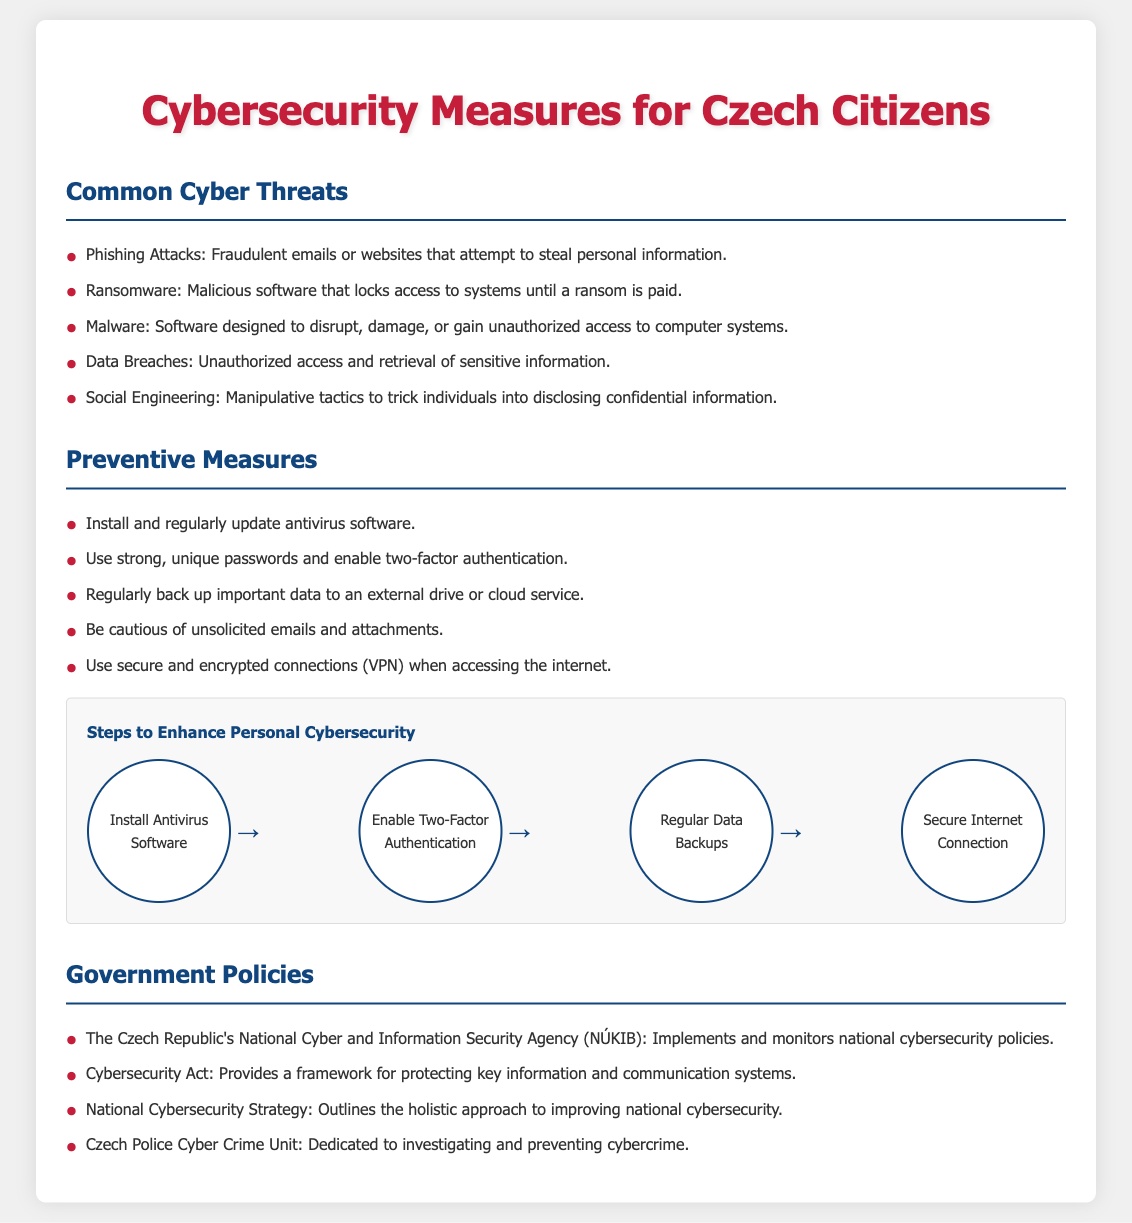What are common cyber threats mentioned? The document lists phishing, ransomware, malware, data breaches, and social engineering as common threats.
Answer: phishing, ransomware, malware, data breaches, social engineering What does NÚKIB stand for? NÚKIB is the abbreviation for the National Cyber and Information Security Agency in the Czech Republic.
Answer: Národní úřad pro kybernetickou a informační bezpečnost What is one preventive measure listed? The document provides several preventive measures; asking for one can yield any like installing antivirus software.
Answer: Install antivirus software What is the purpose of the Cybersecurity Act? The Cybersecurity Act provides a framework for protecting key information and communication systems.
Answer: Protecting key information and communication systems How many steps are there to enhance personal cybersecurity? The flowchart shows a total of four steps for enhancing personal cybersecurity.
Answer: Four steps What type of unit does the Czech Police have for cybercrime? The document mentions that the Czech Police have a dedicated Cyber Crime Unit.
Answer: Cyber Crime Unit What software should be installed regularly? The document specifies that antivirus software should be installed and regularly updated.
Answer: Antivirus software What is a necessary action for securing internet access? Using secure and encrypted connections, such as a VPN, is necessary for securing internet access.
Answer: Use secure and encrypted connections What is the color used for the main title? The main title is colored in a shade of red, specifically a code-like #c41e3a.
Answer: #c41e3a 